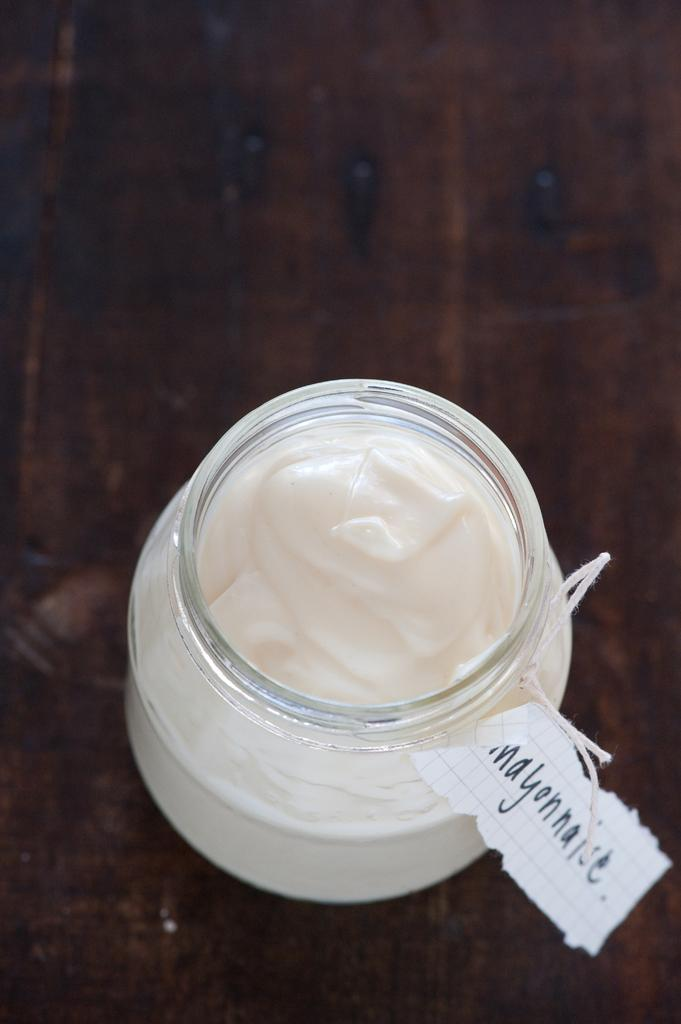<image>
Give a short and clear explanation of the subsequent image. An opened jar on a wooden counter with a tag that says mayonnaise. 